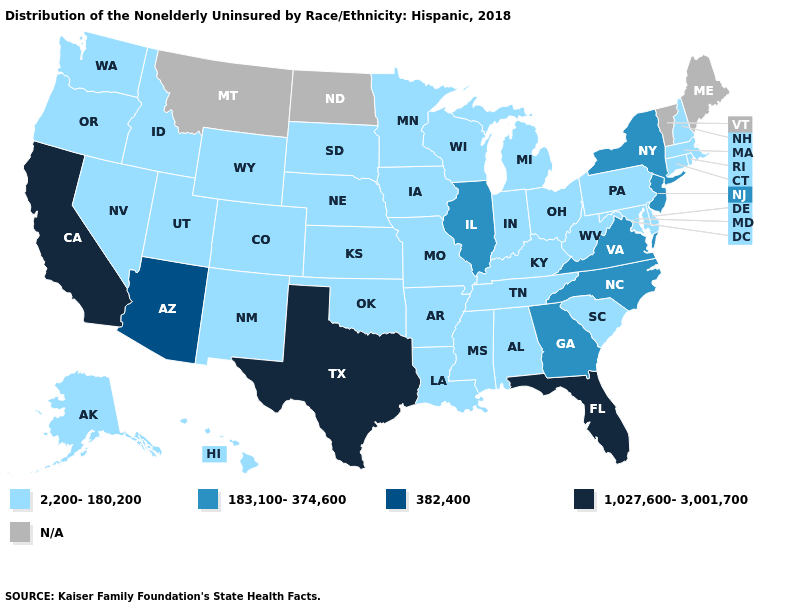What is the lowest value in the Northeast?
Concise answer only. 2,200-180,200. Name the states that have a value in the range 382,400?
Write a very short answer. Arizona. Among the states that border Arkansas , which have the highest value?
Quick response, please. Texas. Does Arizona have the lowest value in the West?
Give a very brief answer. No. What is the value of North Dakota?
Be succinct. N/A. Which states hav the highest value in the MidWest?
Answer briefly. Illinois. What is the value of Maine?
Give a very brief answer. N/A. Name the states that have a value in the range 1,027,600-3,001,700?
Give a very brief answer. California, Florida, Texas. What is the value of Indiana?
Concise answer only. 2,200-180,200. Does the map have missing data?
Give a very brief answer. Yes. What is the value of Illinois?
Write a very short answer. 183,100-374,600. What is the lowest value in the USA?
Give a very brief answer. 2,200-180,200. Name the states that have a value in the range 382,400?
Short answer required. Arizona. Does the map have missing data?
Concise answer only. Yes. 